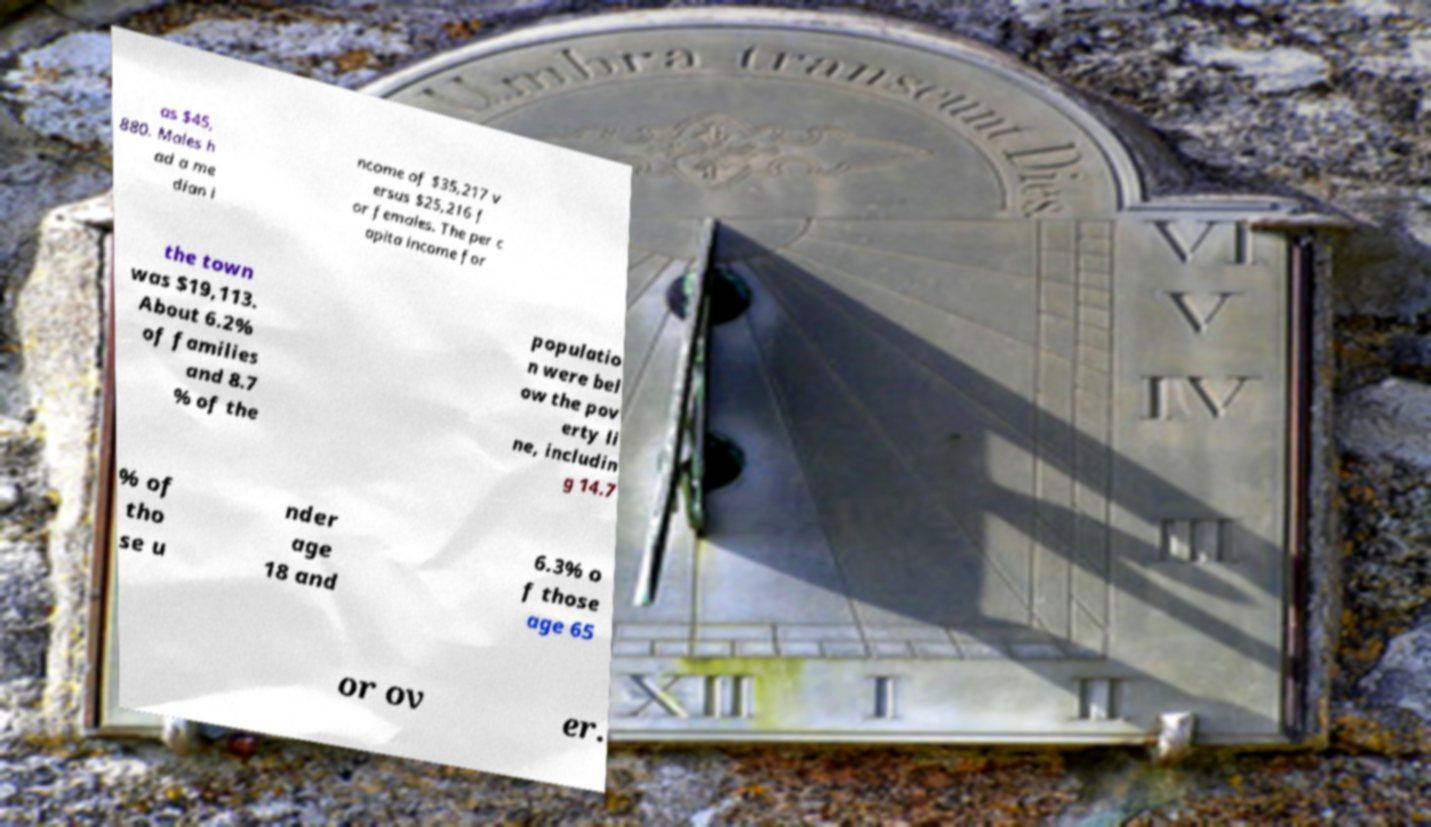Please read and relay the text visible in this image. What does it say? as $45, 880. Males h ad a me dian i ncome of $35,217 v ersus $25,216 f or females. The per c apita income for the town was $19,113. About 6.2% of families and 8.7 % of the populatio n were bel ow the pov erty li ne, includin g 14.7 % of tho se u nder age 18 and 6.3% o f those age 65 or ov er. 